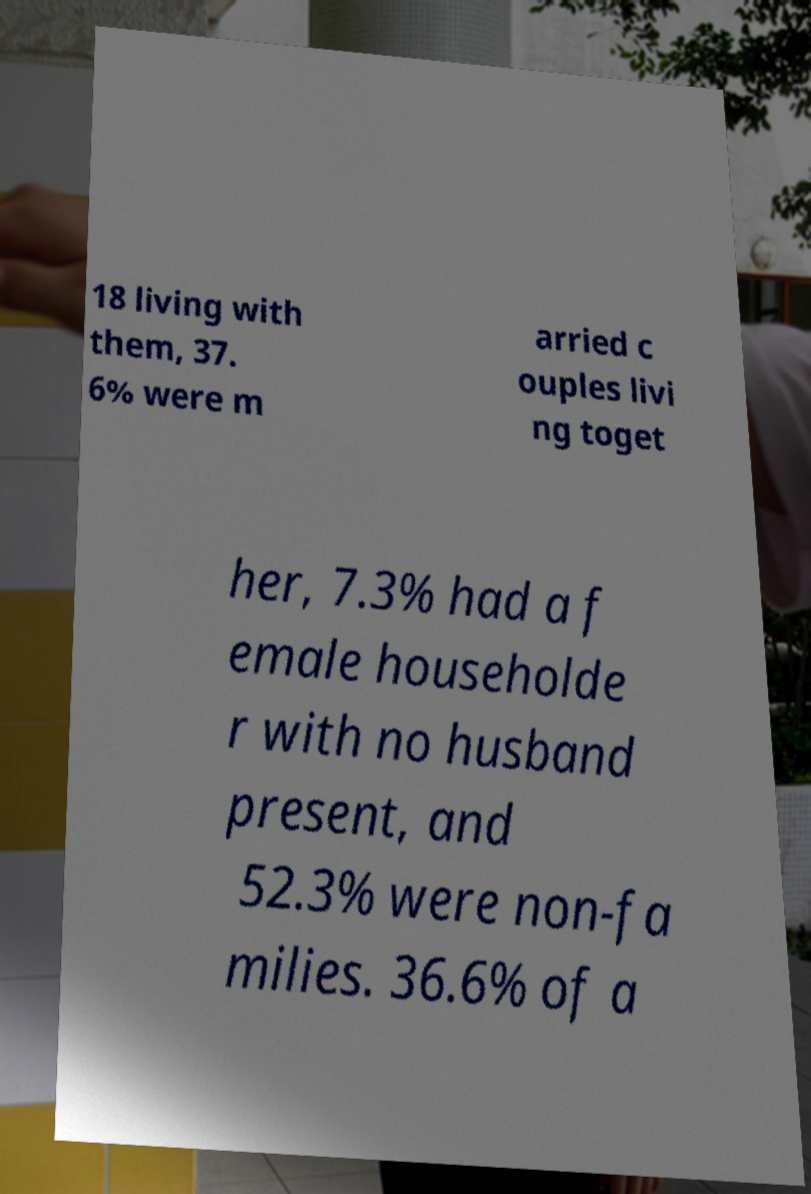Please identify and transcribe the text found in this image. 18 living with them, 37. 6% were m arried c ouples livi ng toget her, 7.3% had a f emale householde r with no husband present, and 52.3% were non-fa milies. 36.6% of a 